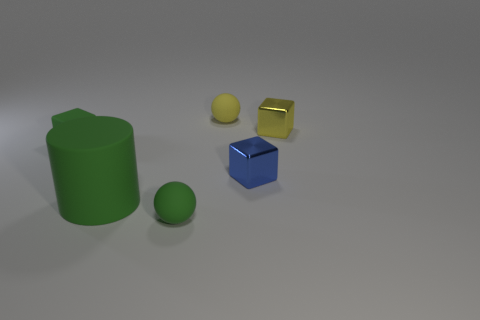The small rubber object that is the same color as the small rubber cube is what shape?
Ensure brevity in your answer.  Sphere. There is a yellow metallic object; is it the same size as the metallic object that is in front of the matte block?
Offer a terse response. Yes. How many cubes are in front of the ball that is to the right of the small rubber ball that is in front of the small yellow cube?
Provide a succinct answer. 3. What is the size of the rubber block that is the same color as the large matte object?
Give a very brief answer. Small. Are there any tiny balls left of the big green cylinder?
Your answer should be compact. No. What is the shape of the yellow matte thing?
Your answer should be compact. Sphere. There is a tiny green matte thing to the right of the small cube left of the small yellow thing to the left of the tiny blue metallic block; what is its shape?
Provide a succinct answer. Sphere. How many other objects are the same shape as the large green matte object?
Make the answer very short. 0. There is a block that is on the left side of the sphere in front of the tiny blue metallic cube; what is its material?
Your answer should be very brief. Rubber. Are there any other things that have the same size as the yellow shiny block?
Give a very brief answer. Yes. 